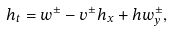<formula> <loc_0><loc_0><loc_500><loc_500>h _ { t } = w ^ { \pm } - v ^ { \pm } h _ { x } + h w ^ { \pm } _ { y } ,</formula> 